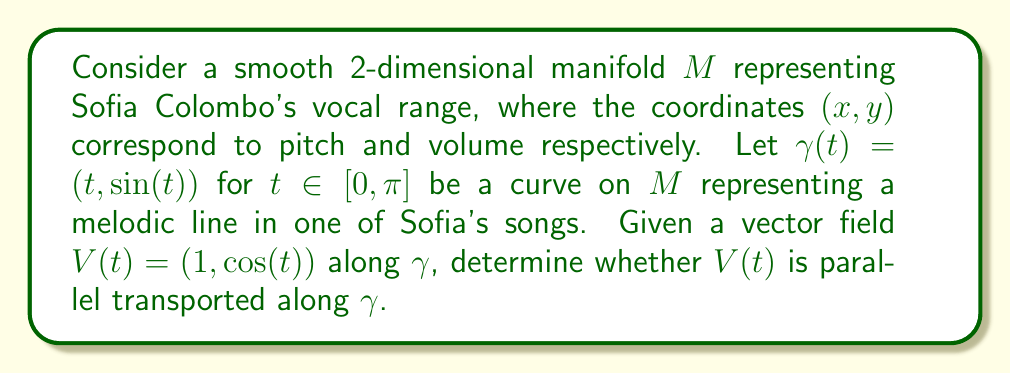Solve this math problem. To determine if $V(t)$ is parallel transported along $\gamma$, we need to check if the covariant derivative of $V(t)$ along $\gamma$ is zero. Let's approach this step-by-step:

1) First, we need to calculate the Christoffel symbols for the manifold. Assuming the manifold has a Riemannian metric $g_{ij}$, the Christoffel symbols are given by:

   $$\Gamma^k_{ij} = \frac{1}{2}g^{kl}(\partial_i g_{jl} + \partial_j g_{il} - \partial_l g_{ij})$$

   However, without specific information about the metric, we can't calculate these explicitly.

2) The covariant derivative of $V$ along $\gamma$ is given by:

   $$\frac{DV}{dt} = \frac{dV^i}{dt} + \Gamma^i_{jk} \frac{d\gamma^j}{dt} V^k$$

3) We can calculate $\frac{d\gamma}{dt} = (1, \cos(t))$ and $\frac{dV}{dt} = (0, -\sin(t))$.

4) Substituting these into the covariant derivative equation:

   $$\frac{DV}{dt} = (0, -\sin(t)) + \Gamma^i_{jk} (1, \cos(t)) (1, \cos(t))$$

5) For $V(t)$ to be parallel transported, we must have $\frac{DV}{dt} = 0$ for all $t$.

6) Without knowing the specific Christoffel symbols, we can't definitively say whether this equation equals zero. However, we can observe that the first component of $\frac{dV}{dt}$ is always zero, while the second component varies with $t$. This suggests that unless the Christoffel symbols have a very specific form to cancel out the $-\sin(t)$ term, $V(t)$ is likely not parallel transported along $\gamma$.

7) In a flat manifold where all Christoffel symbols are zero, $V(t)$ would definitely not be parallel transported as $\frac{DV}{dt} = (0, -\sin(t)) \neq (0,0)$.
Answer: Without specific information about the Christoffel symbols of the manifold, we cannot definitively determine if $V(t)$ is parallel transported along $\gamma$. However, given the varying nature of $V(t)$ and $\frac{dV}{dt}$, it is likely that $V(t)$ is not parallel transported unless the manifold has a very specific geometry that cancels out these variations. 